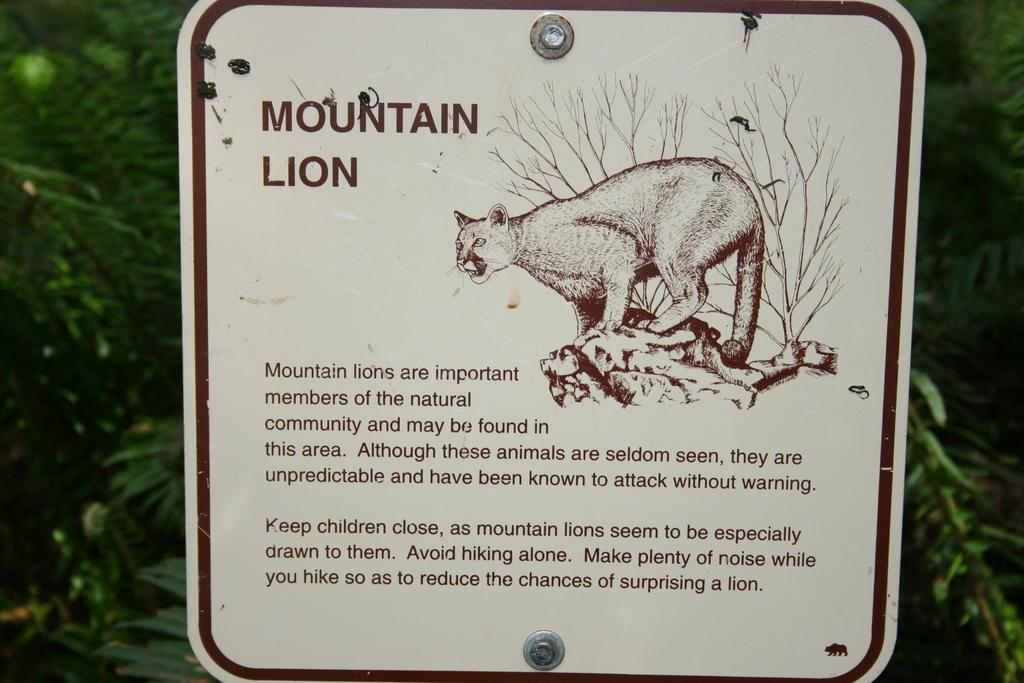What is the main object in the picture? There is a board in the picture. What is depicted on the board? The board has a painting of a lion. Are there any words on the board? Yes, there are words written on the board. What can be seen in the background of the picture? There are leaves visible in the background of the picture. How many snakes are slithering on the board in the image? There are no snakes present in the image; the board has a painting of a lion. 